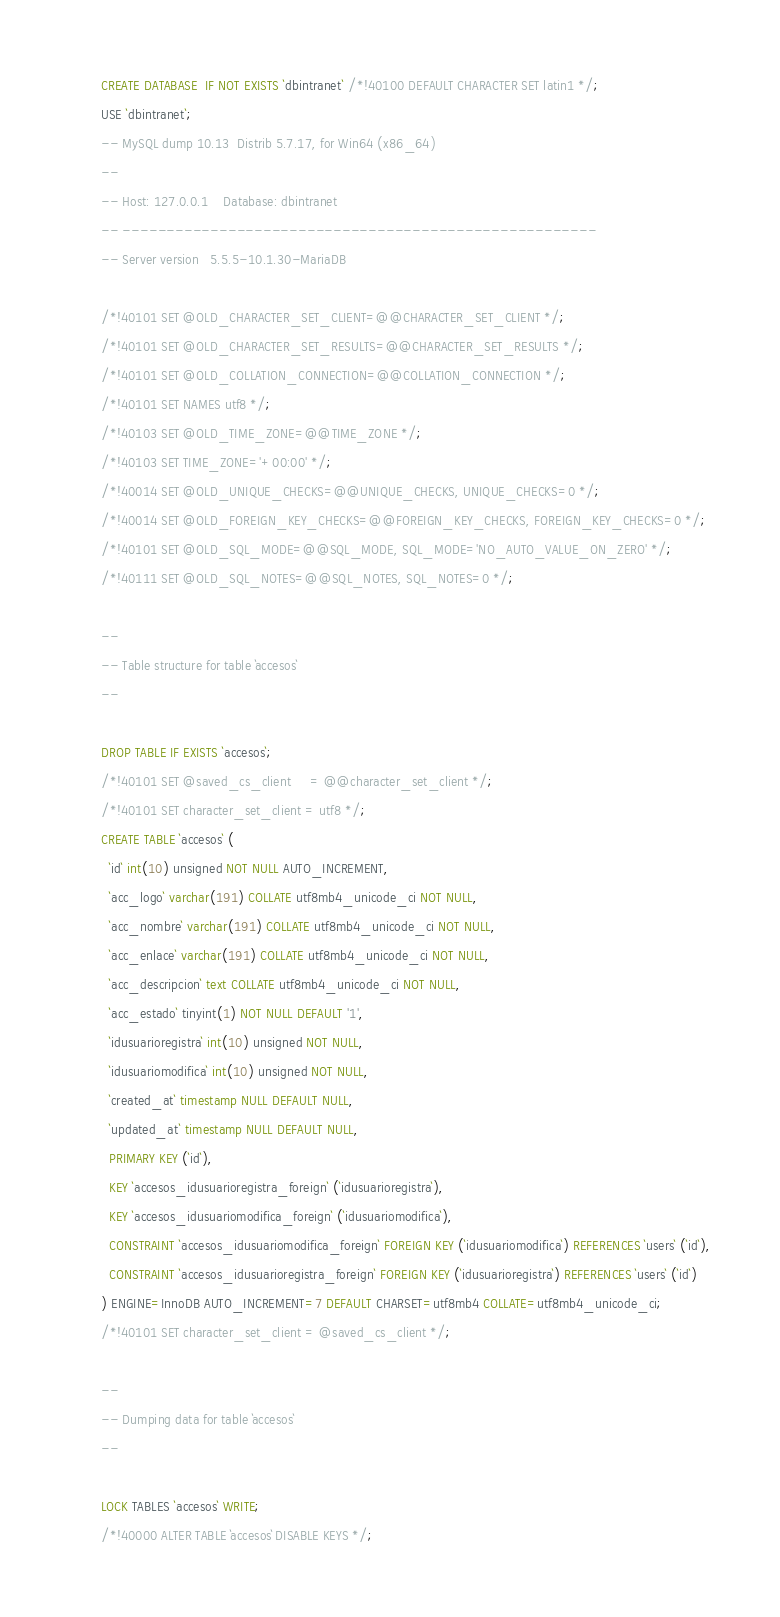Convert code to text. <code><loc_0><loc_0><loc_500><loc_500><_SQL_>CREATE DATABASE  IF NOT EXISTS `dbintranet` /*!40100 DEFAULT CHARACTER SET latin1 */;
USE `dbintranet`;
-- MySQL dump 10.13  Distrib 5.7.17, for Win64 (x86_64)
--
-- Host: 127.0.0.1    Database: dbintranet
-- ------------------------------------------------------
-- Server version	5.5.5-10.1.30-MariaDB

/*!40101 SET @OLD_CHARACTER_SET_CLIENT=@@CHARACTER_SET_CLIENT */;
/*!40101 SET @OLD_CHARACTER_SET_RESULTS=@@CHARACTER_SET_RESULTS */;
/*!40101 SET @OLD_COLLATION_CONNECTION=@@COLLATION_CONNECTION */;
/*!40101 SET NAMES utf8 */;
/*!40103 SET @OLD_TIME_ZONE=@@TIME_ZONE */;
/*!40103 SET TIME_ZONE='+00:00' */;
/*!40014 SET @OLD_UNIQUE_CHECKS=@@UNIQUE_CHECKS, UNIQUE_CHECKS=0 */;
/*!40014 SET @OLD_FOREIGN_KEY_CHECKS=@@FOREIGN_KEY_CHECKS, FOREIGN_KEY_CHECKS=0 */;
/*!40101 SET @OLD_SQL_MODE=@@SQL_MODE, SQL_MODE='NO_AUTO_VALUE_ON_ZERO' */;
/*!40111 SET @OLD_SQL_NOTES=@@SQL_NOTES, SQL_NOTES=0 */;

--
-- Table structure for table `accesos`
--

DROP TABLE IF EXISTS `accesos`;
/*!40101 SET @saved_cs_client     = @@character_set_client */;
/*!40101 SET character_set_client = utf8 */;
CREATE TABLE `accesos` (
  `id` int(10) unsigned NOT NULL AUTO_INCREMENT,
  `acc_logo` varchar(191) COLLATE utf8mb4_unicode_ci NOT NULL,
  `acc_nombre` varchar(191) COLLATE utf8mb4_unicode_ci NOT NULL,
  `acc_enlace` varchar(191) COLLATE utf8mb4_unicode_ci NOT NULL,
  `acc_descripcion` text COLLATE utf8mb4_unicode_ci NOT NULL,
  `acc_estado` tinyint(1) NOT NULL DEFAULT '1',
  `idusuarioregistra` int(10) unsigned NOT NULL,
  `idusuariomodifica` int(10) unsigned NOT NULL,
  `created_at` timestamp NULL DEFAULT NULL,
  `updated_at` timestamp NULL DEFAULT NULL,
  PRIMARY KEY (`id`),
  KEY `accesos_idusuarioregistra_foreign` (`idusuarioregistra`),
  KEY `accesos_idusuariomodifica_foreign` (`idusuariomodifica`),
  CONSTRAINT `accesos_idusuariomodifica_foreign` FOREIGN KEY (`idusuariomodifica`) REFERENCES `users` (`id`),
  CONSTRAINT `accesos_idusuarioregistra_foreign` FOREIGN KEY (`idusuarioregistra`) REFERENCES `users` (`id`)
) ENGINE=InnoDB AUTO_INCREMENT=7 DEFAULT CHARSET=utf8mb4 COLLATE=utf8mb4_unicode_ci;
/*!40101 SET character_set_client = @saved_cs_client */;

--
-- Dumping data for table `accesos`
--

LOCK TABLES `accesos` WRITE;
/*!40000 ALTER TABLE `accesos` DISABLE KEYS */;</code> 